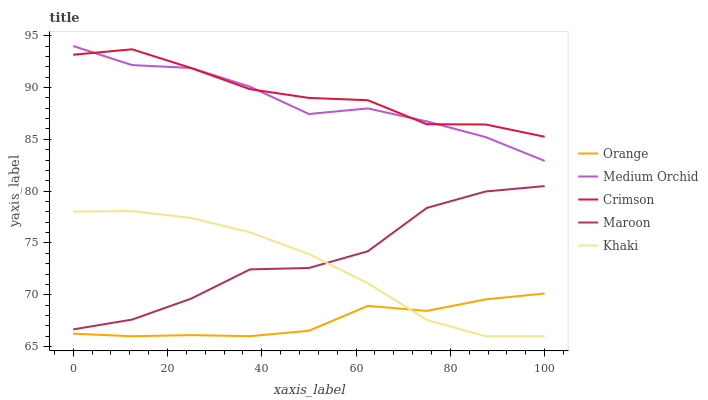Does Orange have the minimum area under the curve?
Answer yes or no. Yes. Does Medium Orchid have the minimum area under the curve?
Answer yes or no. No. Does Medium Orchid have the maximum area under the curve?
Answer yes or no. No. Is Crimson the smoothest?
Answer yes or no. No. Is Crimson the roughest?
Answer yes or no. No. Does Medium Orchid have the lowest value?
Answer yes or no. No. Does Crimson have the highest value?
Answer yes or no. No. Is Maroon less than Medium Orchid?
Answer yes or no. Yes. Is Crimson greater than Maroon?
Answer yes or no. Yes. Does Maroon intersect Medium Orchid?
Answer yes or no. No. 